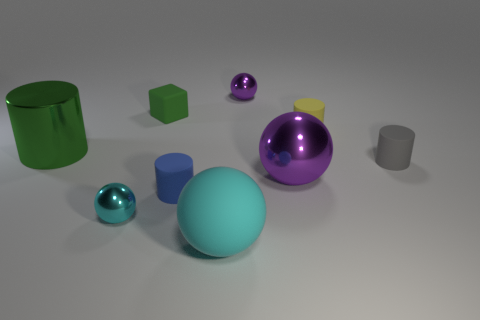Subtract all cyan cylinders. How many cyan balls are left? 2 Subtract all green cylinders. How many cylinders are left? 3 Subtract 2 balls. How many balls are left? 2 Subtract all small cylinders. How many cylinders are left? 1 Subtract all brown cylinders. Subtract all brown spheres. How many cylinders are left? 4 Add 1 blue matte cylinders. How many objects exist? 10 Add 6 purple balls. How many purple balls exist? 8 Subtract 0 cyan cylinders. How many objects are left? 9 Subtract all cylinders. How many objects are left? 5 Subtract all tiny gray spheres. Subtract all matte spheres. How many objects are left? 8 